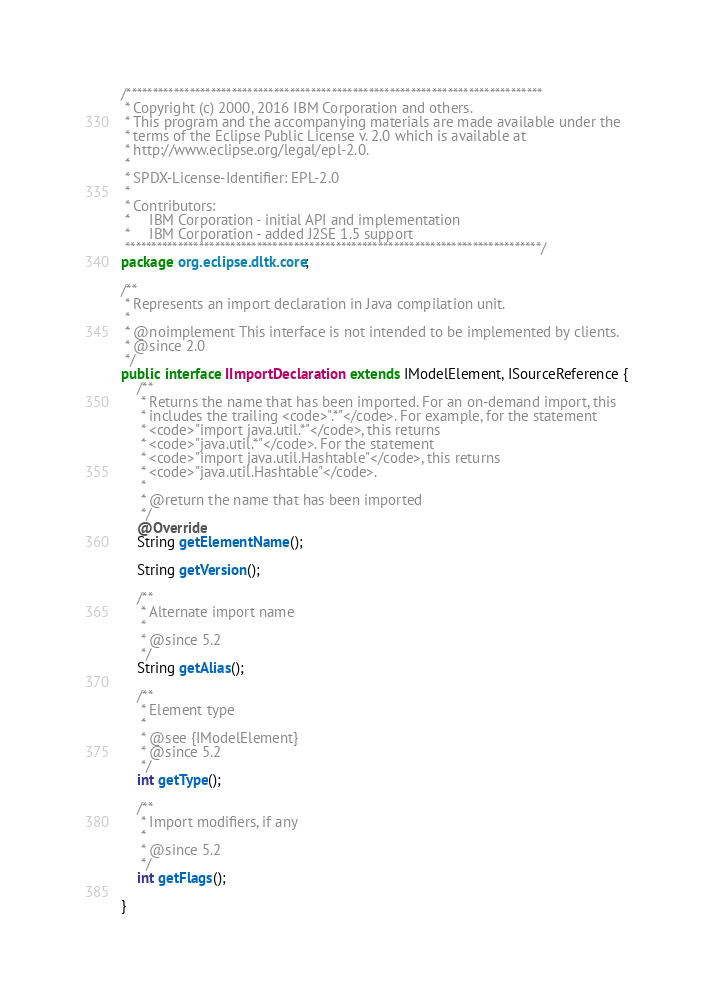Convert code to text. <code><loc_0><loc_0><loc_500><loc_500><_Java_>/*******************************************************************************
 * Copyright (c) 2000, 2016 IBM Corporation and others.
 * This program and the accompanying materials are made available under the
 * terms of the Eclipse Public License v. 2.0 which is available at
 * http://www.eclipse.org/legal/epl-2.0.
 * 
 * SPDX-License-Identifier: EPL-2.0
 *
 * Contributors:
 *     IBM Corporation - initial API and implementation
 *     IBM Corporation - added J2SE 1.5 support
 *******************************************************************************/
package org.eclipse.dltk.core;

/**
 * Represents an import declaration in Java compilation unit.
 * 
 * @noimplement This interface is not intended to be implemented by clients.
 * @since 2.0
 */
public interface IImportDeclaration extends IModelElement, ISourceReference {
	/**
	 * Returns the name that has been imported. For an on-demand import, this
	 * includes the trailing <code>".*"</code>. For example, for the statement
	 * <code>"import java.util.*"</code>, this returns
	 * <code>"java.util.*"</code>. For the statement
	 * <code>"import java.util.Hashtable"</code>, this returns
	 * <code>"java.util.Hashtable"</code>.
	 * 
	 * @return the name that has been imported
	 */
	@Override
	String getElementName();

	String getVersion();

	/**
	 * Alternate import name
	 * 
	 * @since 5.2
	 */
	String getAlias();

	/**
	 * Element type
	 * 
	 * @see {IModelElement}
	 * @since 5.2
	 */
	int getType();

	/**
	 * Import modifiers, if any
	 * 
	 * @since 5.2
	 */
	int getFlags();

}
</code> 